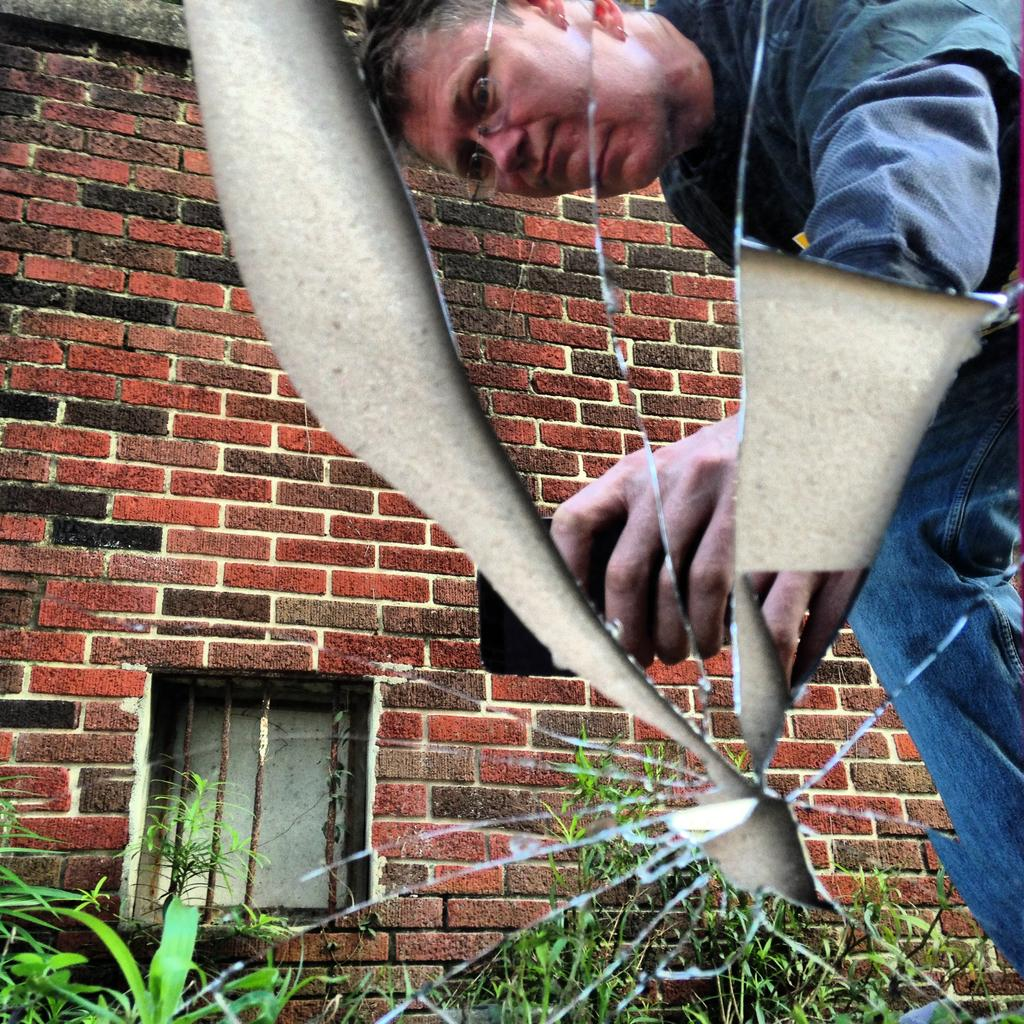What can be seen in the reflection of the image? There is a reflection of a person holding an object in the image. What type of structure is visible in the image? There is a wall in the image. What architectural feature is present in the image? There is a window in the image. What is placed on a broken mirror in the image? There are plants on a broken mirror in the image. What type of bird can be heard singing in the image? There is no bird present in the image, and therefore no singing can be heard. 